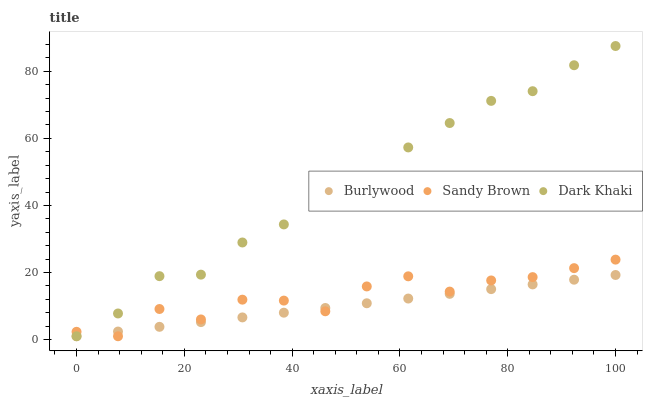Does Burlywood have the minimum area under the curve?
Answer yes or no. Yes. Does Dark Khaki have the maximum area under the curve?
Answer yes or no. Yes. Does Sandy Brown have the minimum area under the curve?
Answer yes or no. No. Does Sandy Brown have the maximum area under the curve?
Answer yes or no. No. Is Burlywood the smoothest?
Answer yes or no. Yes. Is Sandy Brown the roughest?
Answer yes or no. Yes. Is Dark Khaki the smoothest?
Answer yes or no. No. Is Dark Khaki the roughest?
Answer yes or no. No. Does Burlywood have the lowest value?
Answer yes or no. Yes. Does Dark Khaki have the highest value?
Answer yes or no. Yes. Does Sandy Brown have the highest value?
Answer yes or no. No. Does Sandy Brown intersect Dark Khaki?
Answer yes or no. Yes. Is Sandy Brown less than Dark Khaki?
Answer yes or no. No. Is Sandy Brown greater than Dark Khaki?
Answer yes or no. No. 